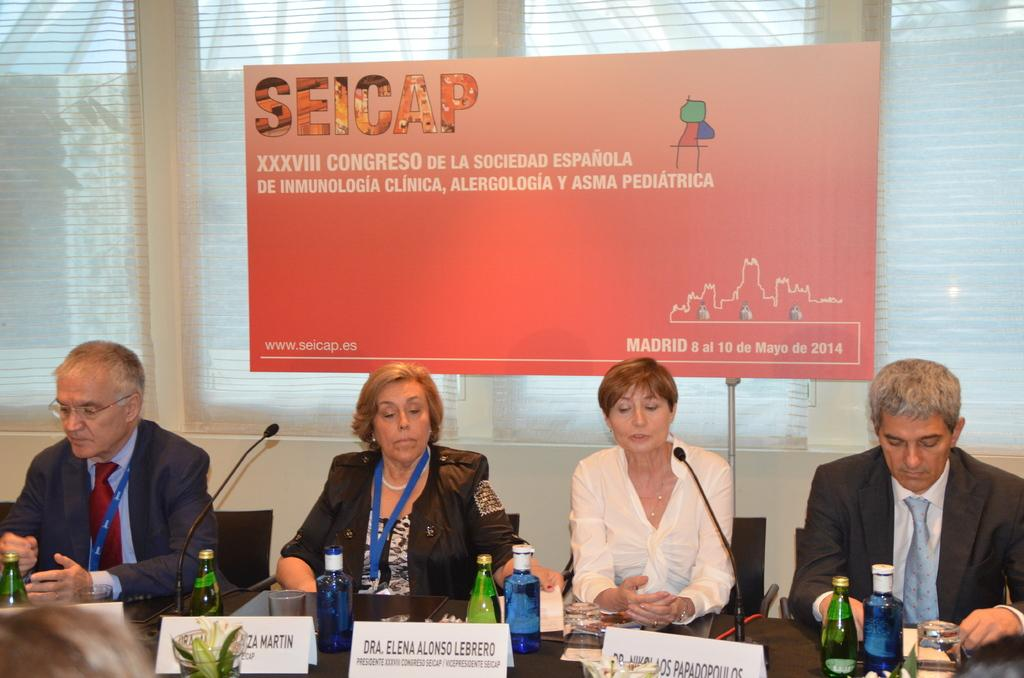<image>
Provide a brief description of the given image. four people sitting at a table in front of a sign that says SEICAP at the top 